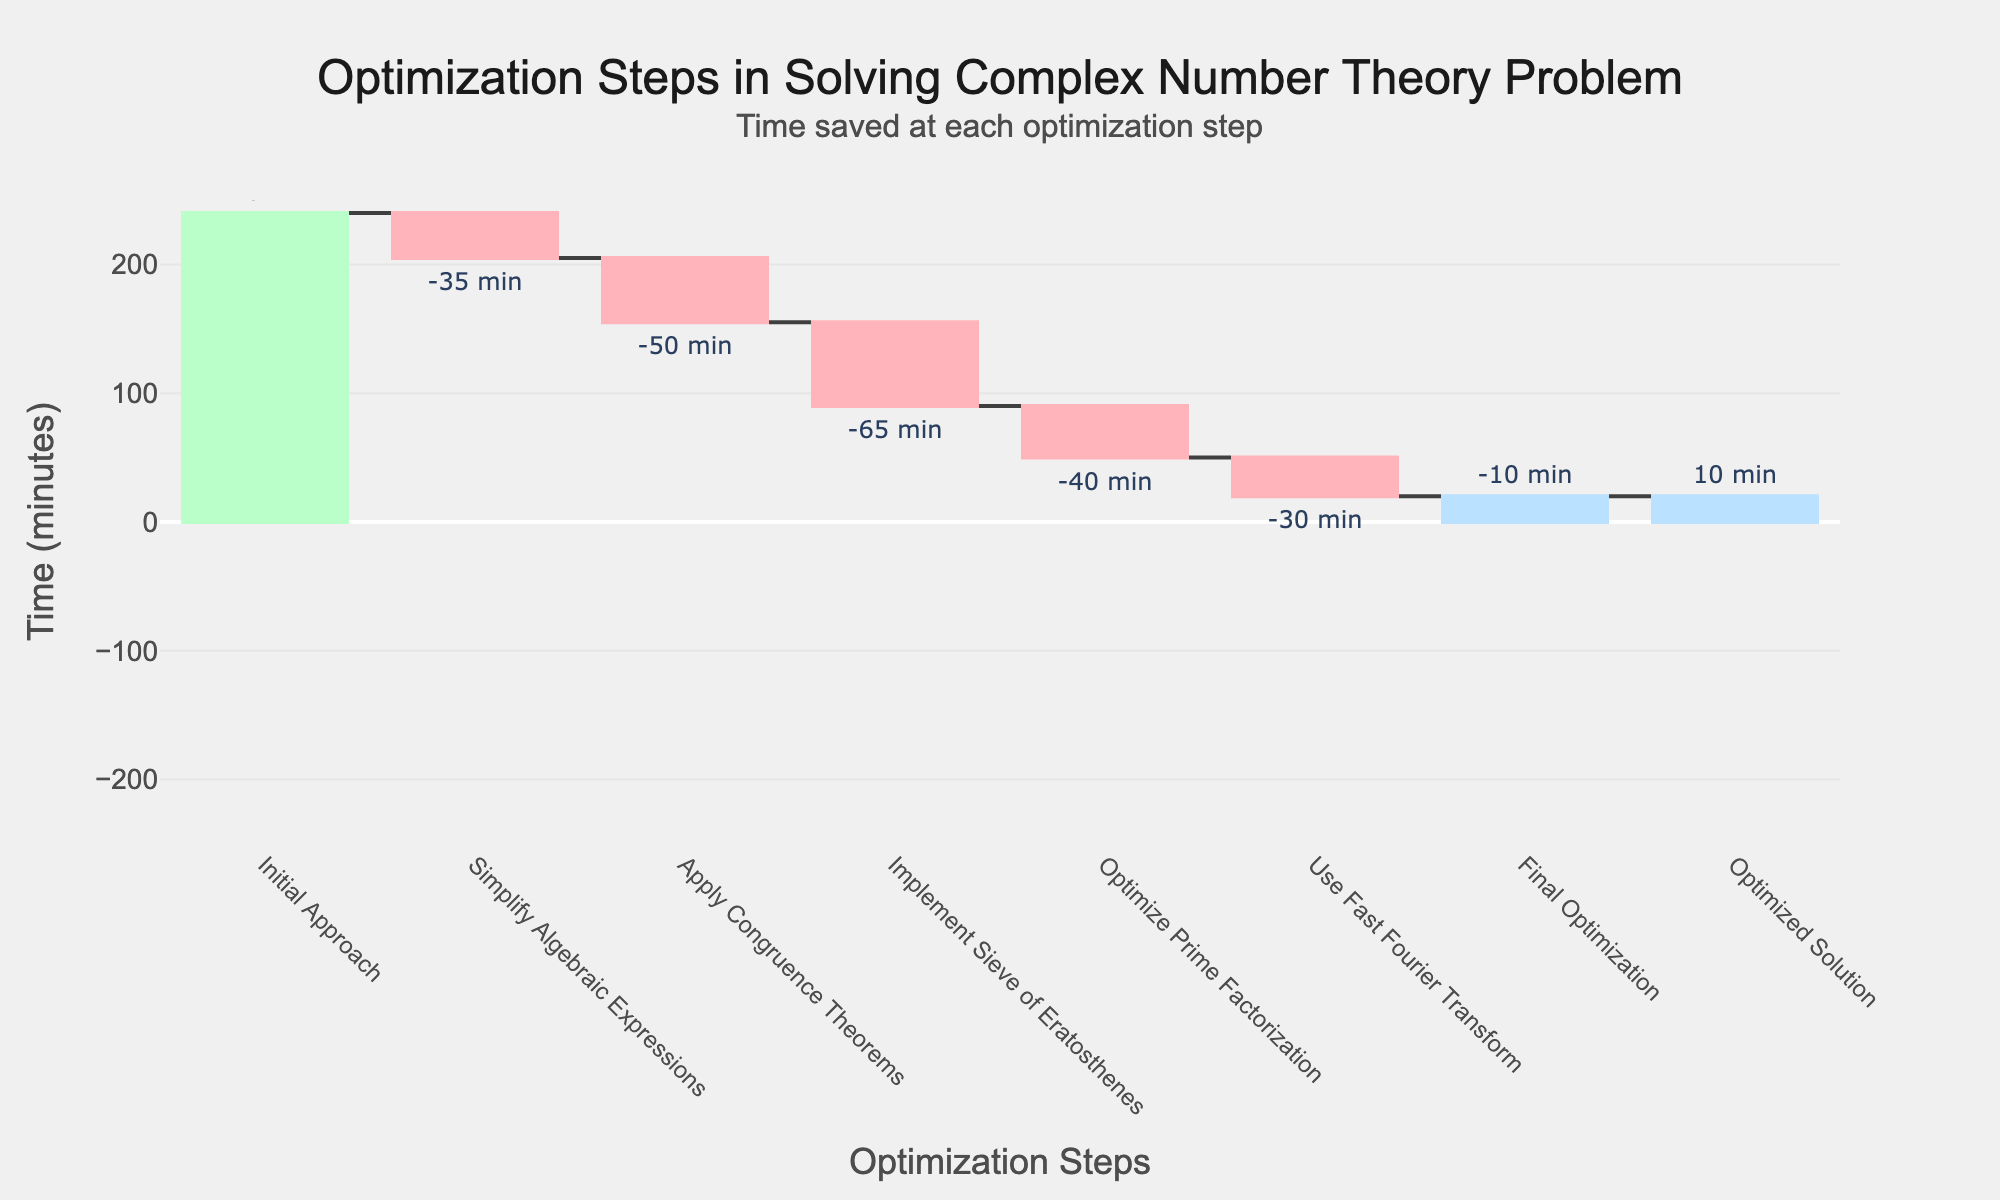What is the total time taken for the initial approach? The total time for the initial approach is directly provided at the starting point of the chart. It's the first value under the "Time (minutes)" column.
Answer: 240 minutes What optimization step saved the most time? The step with the largest negative change value represents the greatest time saved, which is "Implement Sieve of Eratosthenes" with a change of -65 minutes.
Answer: Implement Sieve of Eratosthenes How much total time was saved through all optimization steps before the final solution? Sum of all the negative changes (-35)+(-50)+(-65)+(-40)+(-30)+(-10) = -230 minutes.
Answer: 230 minutes Which optimization step had the least impact on solving time? The smallest negative change value indicates the least impact, which is the "Final Optimization" step, saving 10 minutes.
Answer: Final Optimization By how much did the use of the Fast Fourier Transform reduce the solving time? The reduction in time due to using the Fast Fourier Transform is given as -30 minutes in the chart.
Answer: 30 minutes Compare the solving times before and after applying congruence theorems. Before applying congruence theorems, the time was reduced by 35 minutes. After applying it, an additional 50 minutes were saved.
Answer: Step savings: 35 minutes before, 50 minutes after What percentage of the initial solving time was saved by simplifying algebraic expressions? Simplifying algebraic expressions saved 35 minutes. The percentage is calculated as (35 / 240) * 100% = 14.58%
Answer: 14.58% What is the final optimized solving time? The final optimized solving time is presented as the last value in the chart, which is 10 minutes.
Answer: 10 minutes How much was the average time saved per optimization step? (excluding initial and final values) Sum the changes of the six steps: -230 minutes. Divide by 6 to get the average: -230 / 6 ≈ -38.33 minutes.
Answer: 38.33 minutes Why does the chart include a positive change at the final optimization step? In a waterfall chart, a positive change can indicate a completion or summary step, showing the final outcome effectively (here, it points to the final optimized time).
Answer: To show the final outcome Which optimization technique contributed most significantly to reducing the initial solving time? 'Implement Sieve of Eratosthenes' shows the largest saving of 65 minutes, making it the most significant technique in reducing solving time.
Answer: Implement Sieve of Eratosthenes 